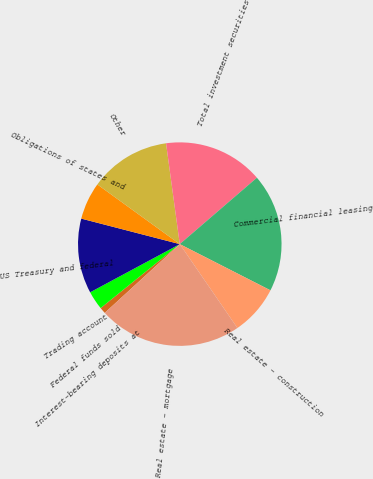<chart> <loc_0><loc_0><loc_500><loc_500><pie_chart><fcel>Interest-bearing deposits at<fcel>Federal funds sold<fcel>Trading account<fcel>US Treasury and federal<fcel>Obligations of states and<fcel>Other<fcel>Total investment securities<fcel>Commercial financial leasing<fcel>Real estate - construction<fcel>Real estate - mortgage<nl><fcel>0.0%<fcel>0.99%<fcel>2.97%<fcel>11.88%<fcel>5.94%<fcel>12.87%<fcel>15.84%<fcel>18.81%<fcel>7.92%<fcel>22.77%<nl></chart> 